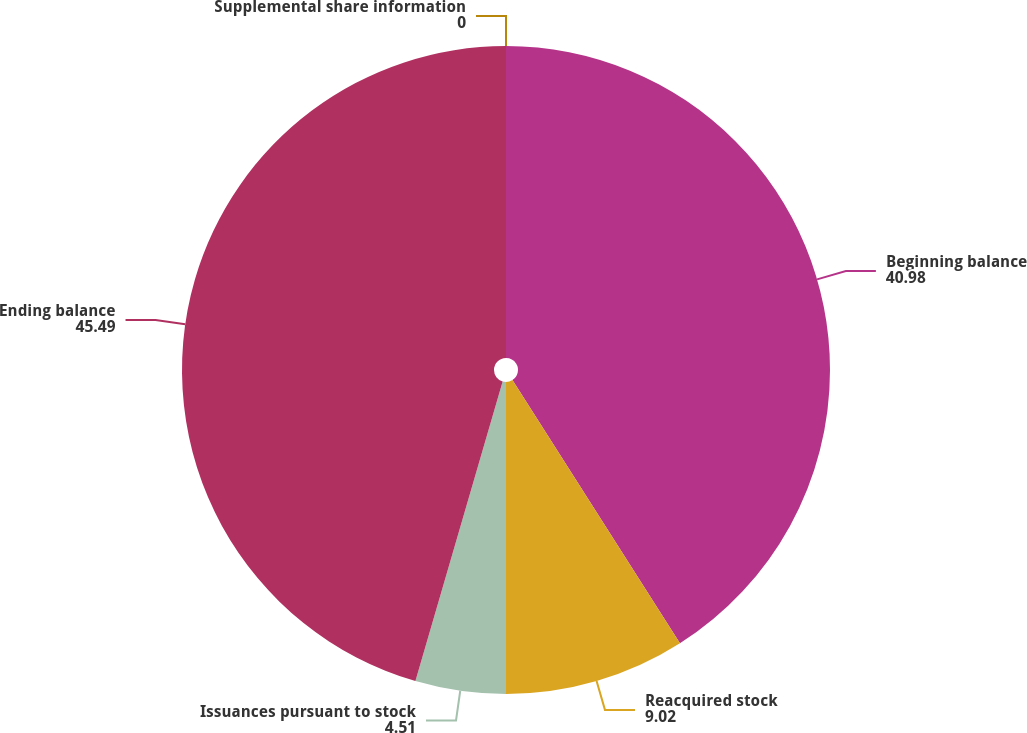Convert chart. <chart><loc_0><loc_0><loc_500><loc_500><pie_chart><fcel>Supplemental share information<fcel>Beginning balance<fcel>Reacquired stock<fcel>Issuances pursuant to stock<fcel>Ending balance<nl><fcel>0.0%<fcel>40.98%<fcel>9.02%<fcel>4.51%<fcel>45.49%<nl></chart> 